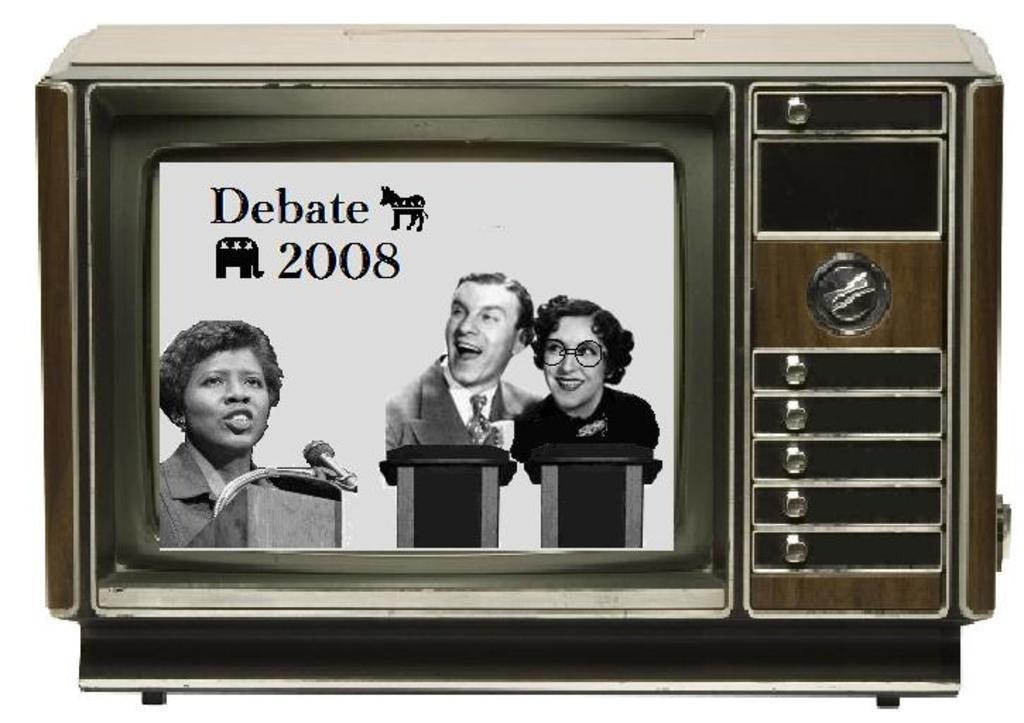When was the debate?
Provide a short and direct response. 2008. 